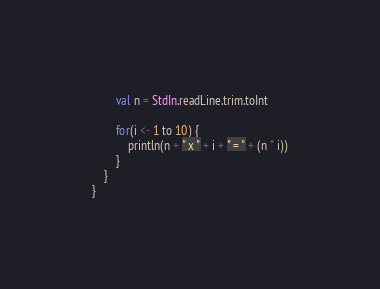<code> <loc_0><loc_0><loc_500><loc_500><_Scala_>        val n = StdIn.readLine.trim.toInt
        
        for(i <- 1 to 10) {
            println(n + " x " + i + " = " + (n * i))
        }
    }
}
</code> 